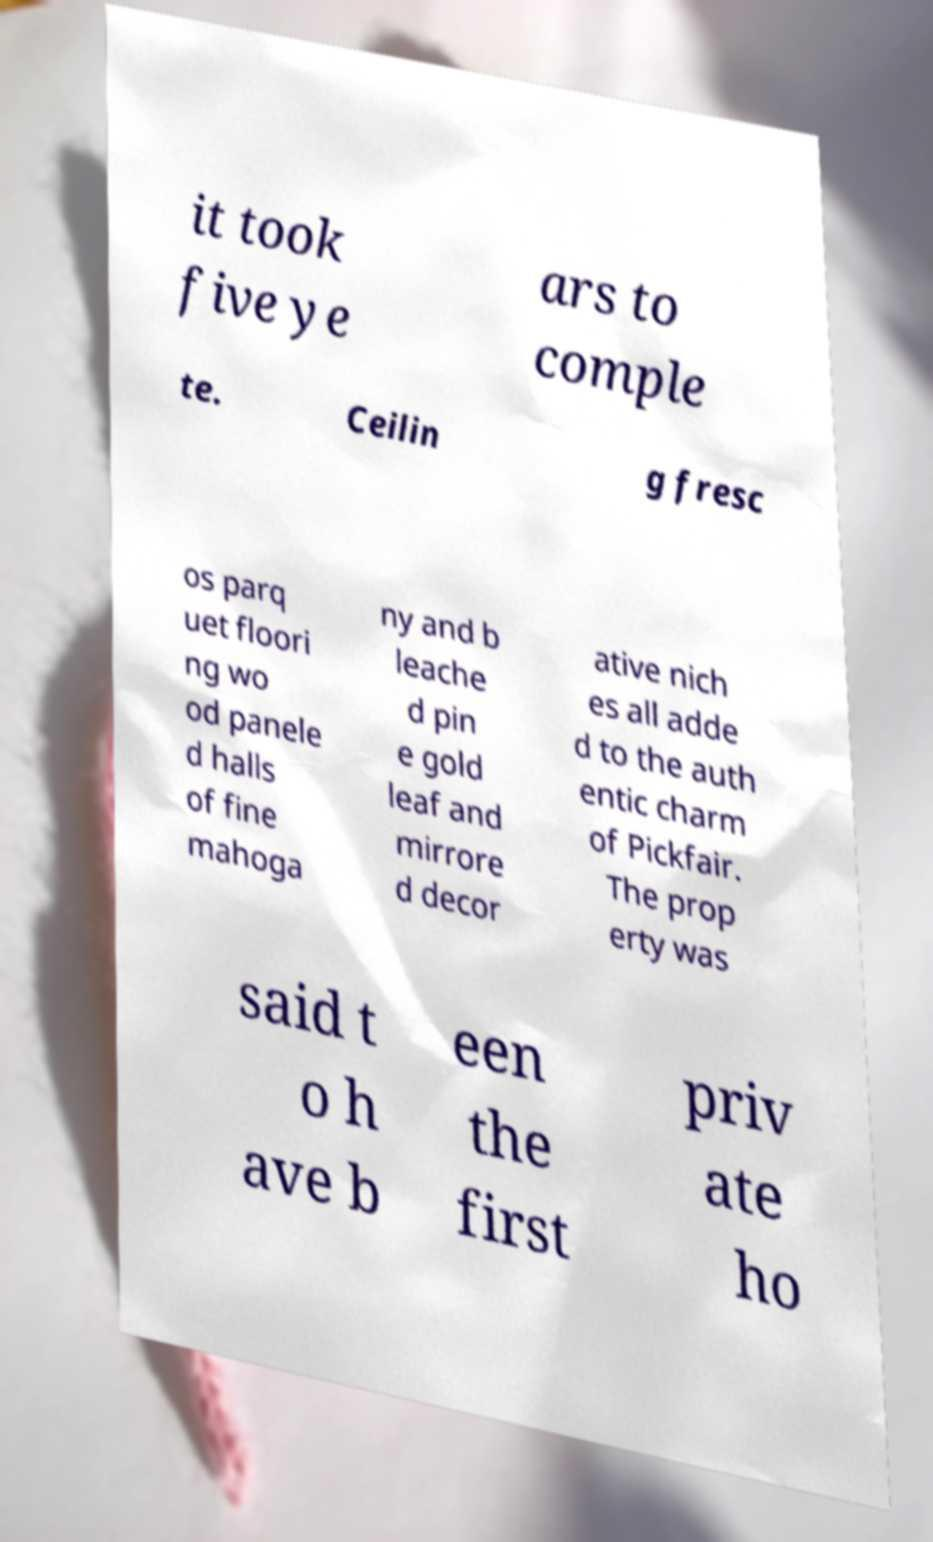Can you read and provide the text displayed in the image?This photo seems to have some interesting text. Can you extract and type it out for me? it took five ye ars to comple te. Ceilin g fresc os parq uet floori ng wo od panele d halls of fine mahoga ny and b leache d pin e gold leaf and mirrore d decor ative nich es all adde d to the auth entic charm of Pickfair. The prop erty was said t o h ave b een the first priv ate ho 